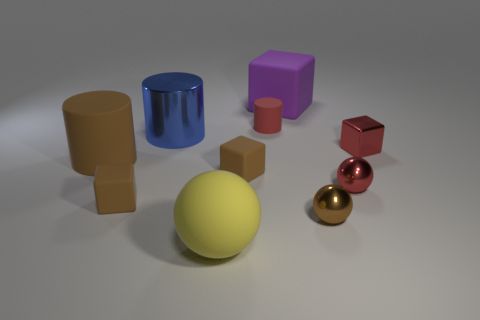Subtract all cubes. How many objects are left? 6 Subtract 1 brown spheres. How many objects are left? 9 Subtract all purple rubber things. Subtract all blue cylinders. How many objects are left? 8 Add 4 large spheres. How many large spheres are left? 5 Add 1 large yellow rubber cubes. How many large yellow rubber cubes exist? 1 